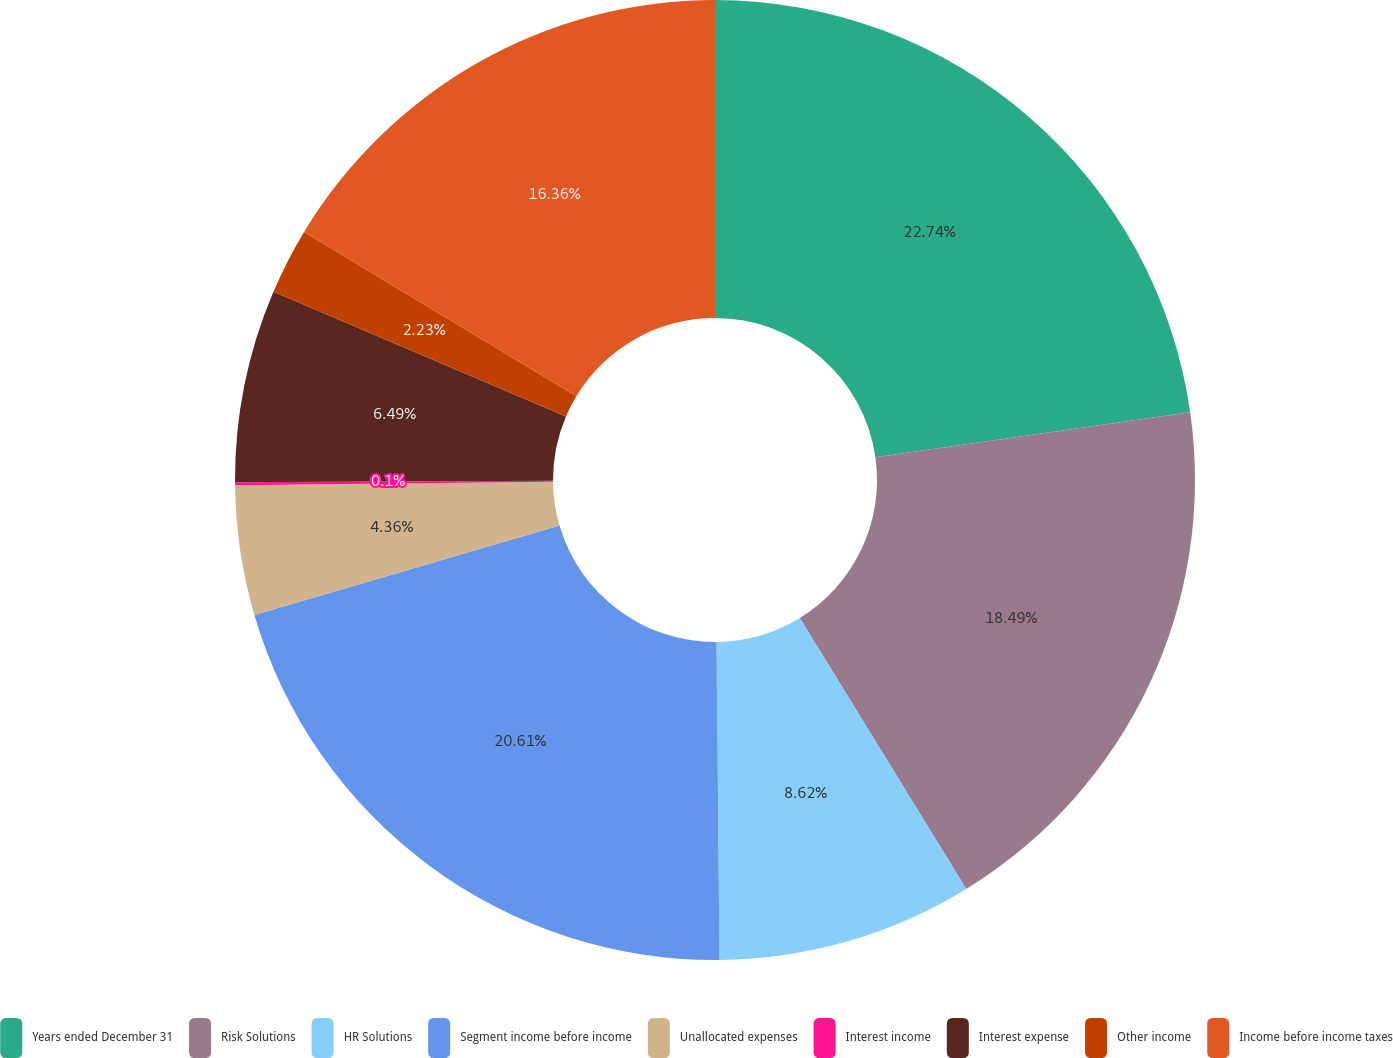Convert chart. <chart><loc_0><loc_0><loc_500><loc_500><pie_chart><fcel>Years ended December 31<fcel>Risk Solutions<fcel>HR Solutions<fcel>Segment income before income<fcel>Unallocated expenses<fcel>Interest income<fcel>Interest expense<fcel>Other income<fcel>Income before income taxes<nl><fcel>22.75%<fcel>18.49%<fcel>8.62%<fcel>20.62%<fcel>4.36%<fcel>0.1%<fcel>6.49%<fcel>2.23%<fcel>16.36%<nl></chart> 